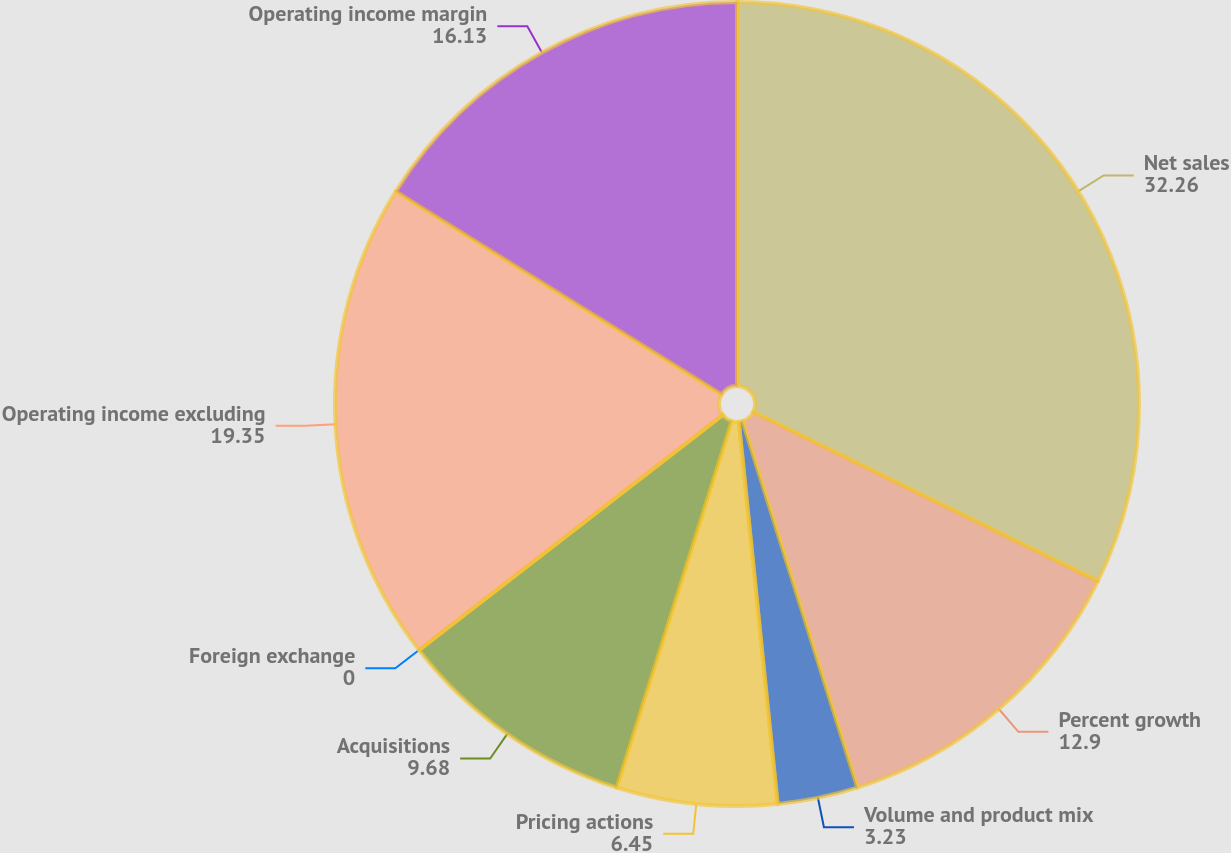Convert chart. <chart><loc_0><loc_0><loc_500><loc_500><pie_chart><fcel>Net sales<fcel>Percent growth<fcel>Volume and product mix<fcel>Pricing actions<fcel>Acquisitions<fcel>Foreign exchange<fcel>Operating income excluding<fcel>Operating income margin<nl><fcel>32.26%<fcel>12.9%<fcel>3.23%<fcel>6.45%<fcel>9.68%<fcel>0.0%<fcel>19.35%<fcel>16.13%<nl></chart> 